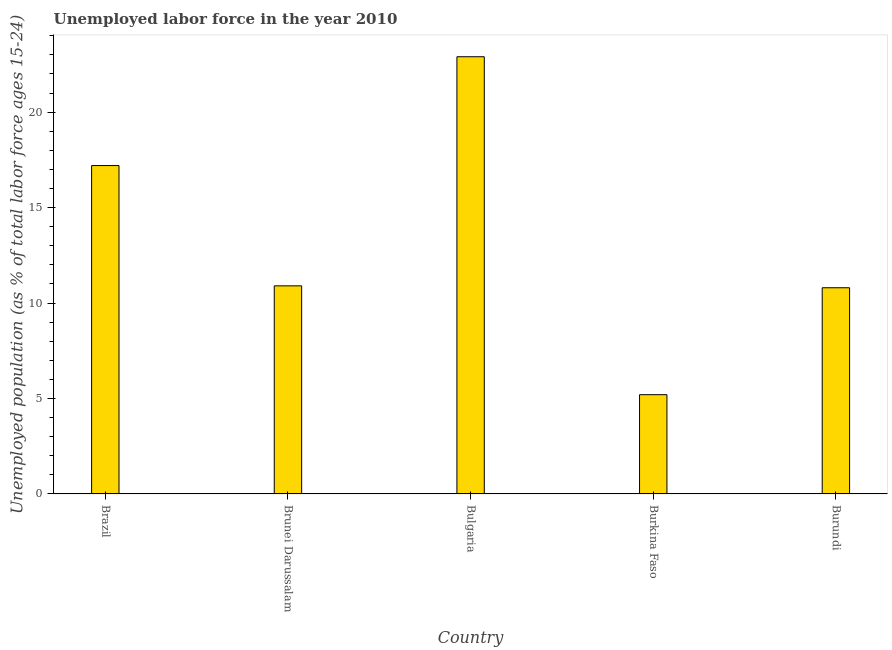Does the graph contain any zero values?
Ensure brevity in your answer.  No. What is the title of the graph?
Make the answer very short. Unemployed labor force in the year 2010. What is the label or title of the X-axis?
Provide a succinct answer. Country. What is the label or title of the Y-axis?
Your response must be concise. Unemployed population (as % of total labor force ages 15-24). What is the total unemployed youth population in Brunei Darussalam?
Offer a terse response. 10.9. Across all countries, what is the maximum total unemployed youth population?
Make the answer very short. 22.9. Across all countries, what is the minimum total unemployed youth population?
Ensure brevity in your answer.  5.2. In which country was the total unemployed youth population maximum?
Give a very brief answer. Bulgaria. In which country was the total unemployed youth population minimum?
Ensure brevity in your answer.  Burkina Faso. What is the sum of the total unemployed youth population?
Offer a terse response. 67. What is the difference between the total unemployed youth population in Brunei Darussalam and Burkina Faso?
Give a very brief answer. 5.7. What is the median total unemployed youth population?
Ensure brevity in your answer.  10.9. What is the ratio of the total unemployed youth population in Brazil to that in Brunei Darussalam?
Your answer should be compact. 1.58. Is the difference between the total unemployed youth population in Brazil and Burkina Faso greater than the difference between any two countries?
Your response must be concise. No. What is the difference between the highest and the second highest total unemployed youth population?
Ensure brevity in your answer.  5.7. What is the difference between the highest and the lowest total unemployed youth population?
Your answer should be very brief. 17.7. How many bars are there?
Give a very brief answer. 5. What is the difference between two consecutive major ticks on the Y-axis?
Offer a very short reply. 5. What is the Unemployed population (as % of total labor force ages 15-24) in Brazil?
Your answer should be very brief. 17.2. What is the Unemployed population (as % of total labor force ages 15-24) of Brunei Darussalam?
Ensure brevity in your answer.  10.9. What is the Unemployed population (as % of total labor force ages 15-24) of Bulgaria?
Offer a very short reply. 22.9. What is the Unemployed population (as % of total labor force ages 15-24) of Burkina Faso?
Your answer should be very brief. 5.2. What is the Unemployed population (as % of total labor force ages 15-24) of Burundi?
Ensure brevity in your answer.  10.8. What is the difference between the Unemployed population (as % of total labor force ages 15-24) in Brazil and Brunei Darussalam?
Offer a very short reply. 6.3. What is the difference between the Unemployed population (as % of total labor force ages 15-24) in Brazil and Burkina Faso?
Your answer should be compact. 12. What is the difference between the Unemployed population (as % of total labor force ages 15-24) in Brunei Darussalam and Burkina Faso?
Your answer should be very brief. 5.7. What is the difference between the Unemployed population (as % of total labor force ages 15-24) in Bulgaria and Burundi?
Your answer should be compact. 12.1. What is the ratio of the Unemployed population (as % of total labor force ages 15-24) in Brazil to that in Brunei Darussalam?
Provide a succinct answer. 1.58. What is the ratio of the Unemployed population (as % of total labor force ages 15-24) in Brazil to that in Bulgaria?
Make the answer very short. 0.75. What is the ratio of the Unemployed population (as % of total labor force ages 15-24) in Brazil to that in Burkina Faso?
Provide a succinct answer. 3.31. What is the ratio of the Unemployed population (as % of total labor force ages 15-24) in Brazil to that in Burundi?
Ensure brevity in your answer.  1.59. What is the ratio of the Unemployed population (as % of total labor force ages 15-24) in Brunei Darussalam to that in Bulgaria?
Provide a short and direct response. 0.48. What is the ratio of the Unemployed population (as % of total labor force ages 15-24) in Brunei Darussalam to that in Burkina Faso?
Give a very brief answer. 2.1. What is the ratio of the Unemployed population (as % of total labor force ages 15-24) in Brunei Darussalam to that in Burundi?
Keep it short and to the point. 1.01. What is the ratio of the Unemployed population (as % of total labor force ages 15-24) in Bulgaria to that in Burkina Faso?
Your answer should be very brief. 4.4. What is the ratio of the Unemployed population (as % of total labor force ages 15-24) in Bulgaria to that in Burundi?
Your answer should be compact. 2.12. What is the ratio of the Unemployed population (as % of total labor force ages 15-24) in Burkina Faso to that in Burundi?
Make the answer very short. 0.48. 